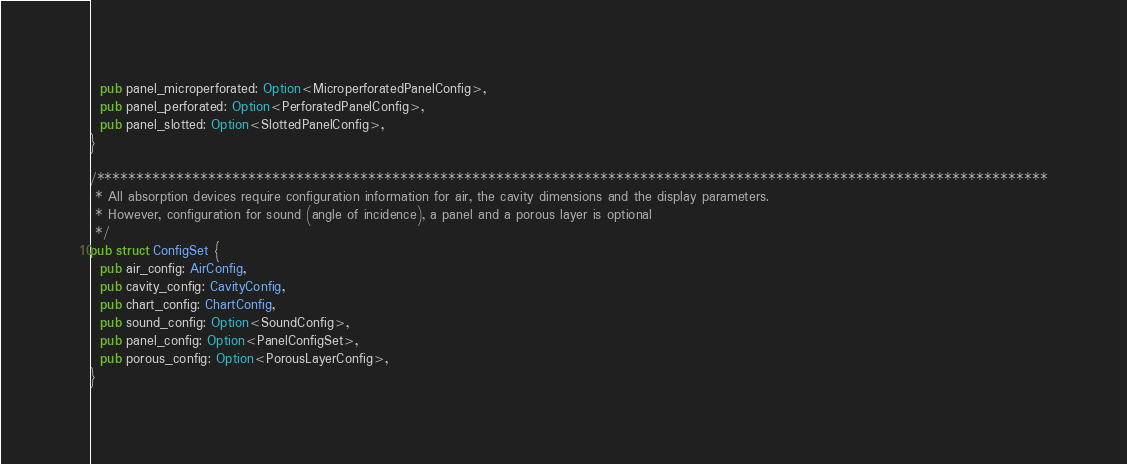<code> <loc_0><loc_0><loc_500><loc_500><_Rust_>  pub panel_microperforated: Option<MicroperforatedPanelConfig>,
  pub panel_perforated: Option<PerforatedPanelConfig>,
  pub panel_slotted: Option<SlottedPanelConfig>,
}

/***********************************************************************************************************************
 * All absorption devices require configuration information for air, the cavity dimensions and the display parameters.
 * However, configuration for sound (angle of incidence), a panel and a porous layer is optional
 */
pub struct ConfigSet {
  pub air_config: AirConfig,
  pub cavity_config: CavityConfig,
  pub chart_config: ChartConfig,
  pub sound_config: Option<SoundConfig>,
  pub panel_config: Option<PanelConfigSet>,
  pub porous_config: Option<PorousLayerConfig>,
}
</code> 